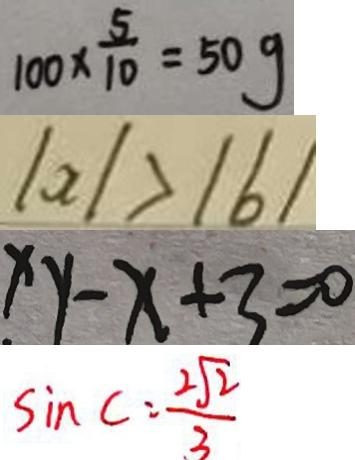<formula> <loc_0><loc_0><loc_500><loc_500>1 0 0 \times \frac { 5 } { 1 0 } = 5 0 g 
 \vert a \vert > \vert b \vert 
 x y - x + 3 = 0 
 \sin C = \frac { 2 \sqrt { 2 } } { 3 }</formula> 